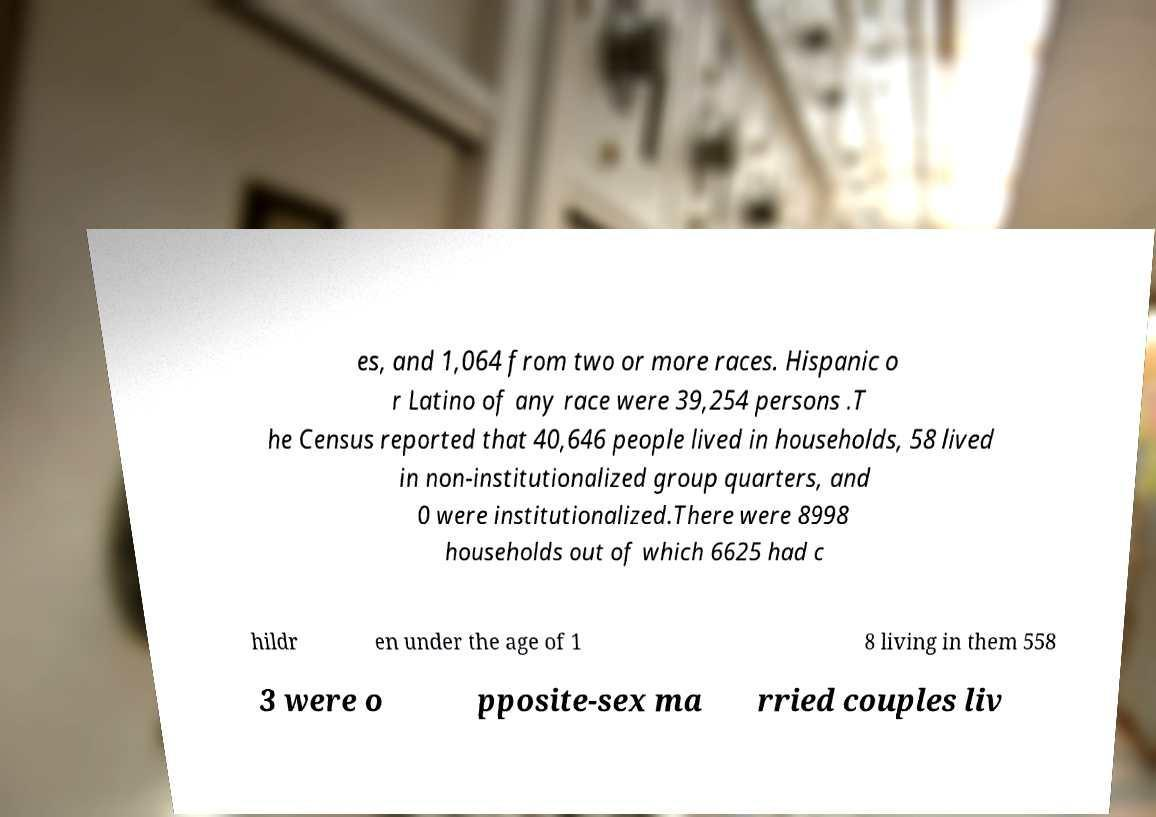Could you assist in decoding the text presented in this image and type it out clearly? es, and 1,064 from two or more races. Hispanic o r Latino of any race were 39,254 persons .T he Census reported that 40,646 people lived in households, 58 lived in non-institutionalized group quarters, and 0 were institutionalized.There were 8998 households out of which 6625 had c hildr en under the age of 1 8 living in them 558 3 were o pposite-sex ma rried couples liv 